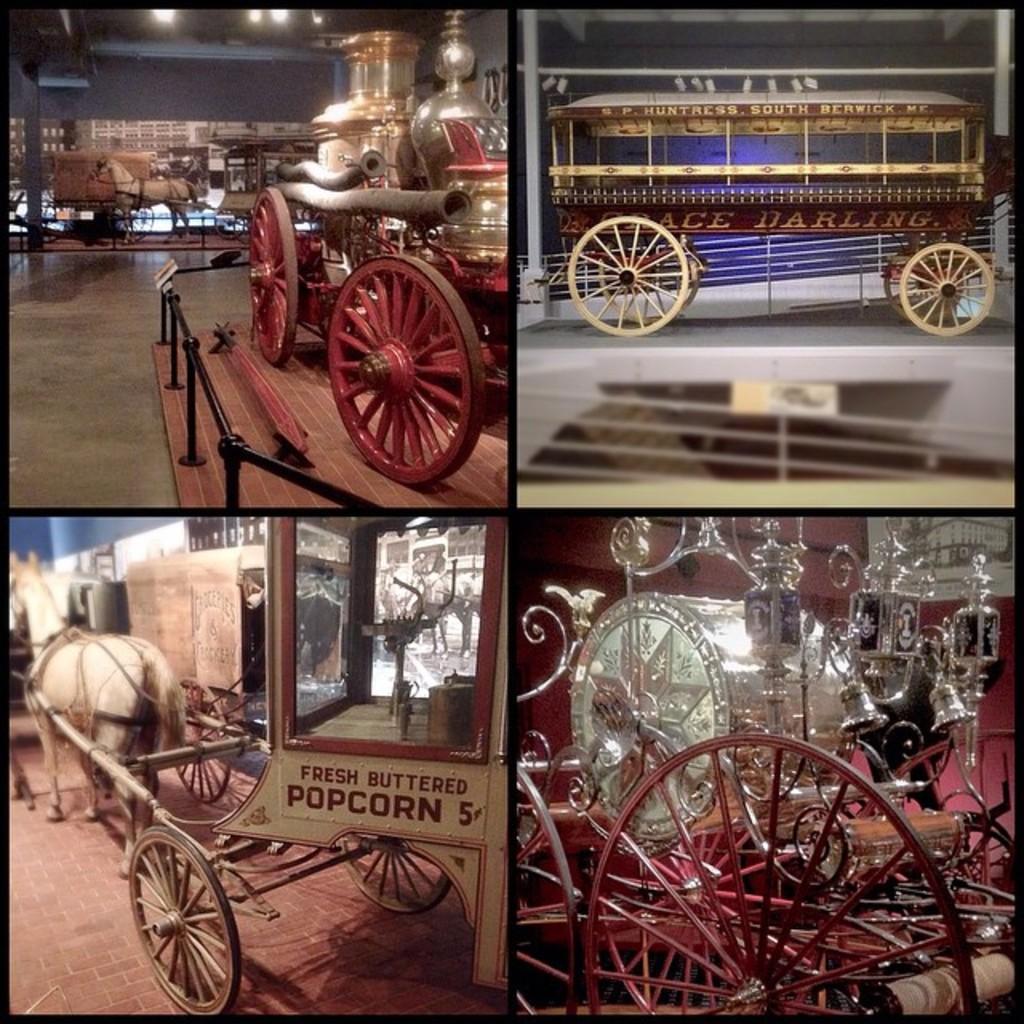How would you summarize this image in a sentence or two? This is an edited image in this image i can see some vehicles, horse, wheels, fence, lights and some other objects. A the bottom there is floor. 